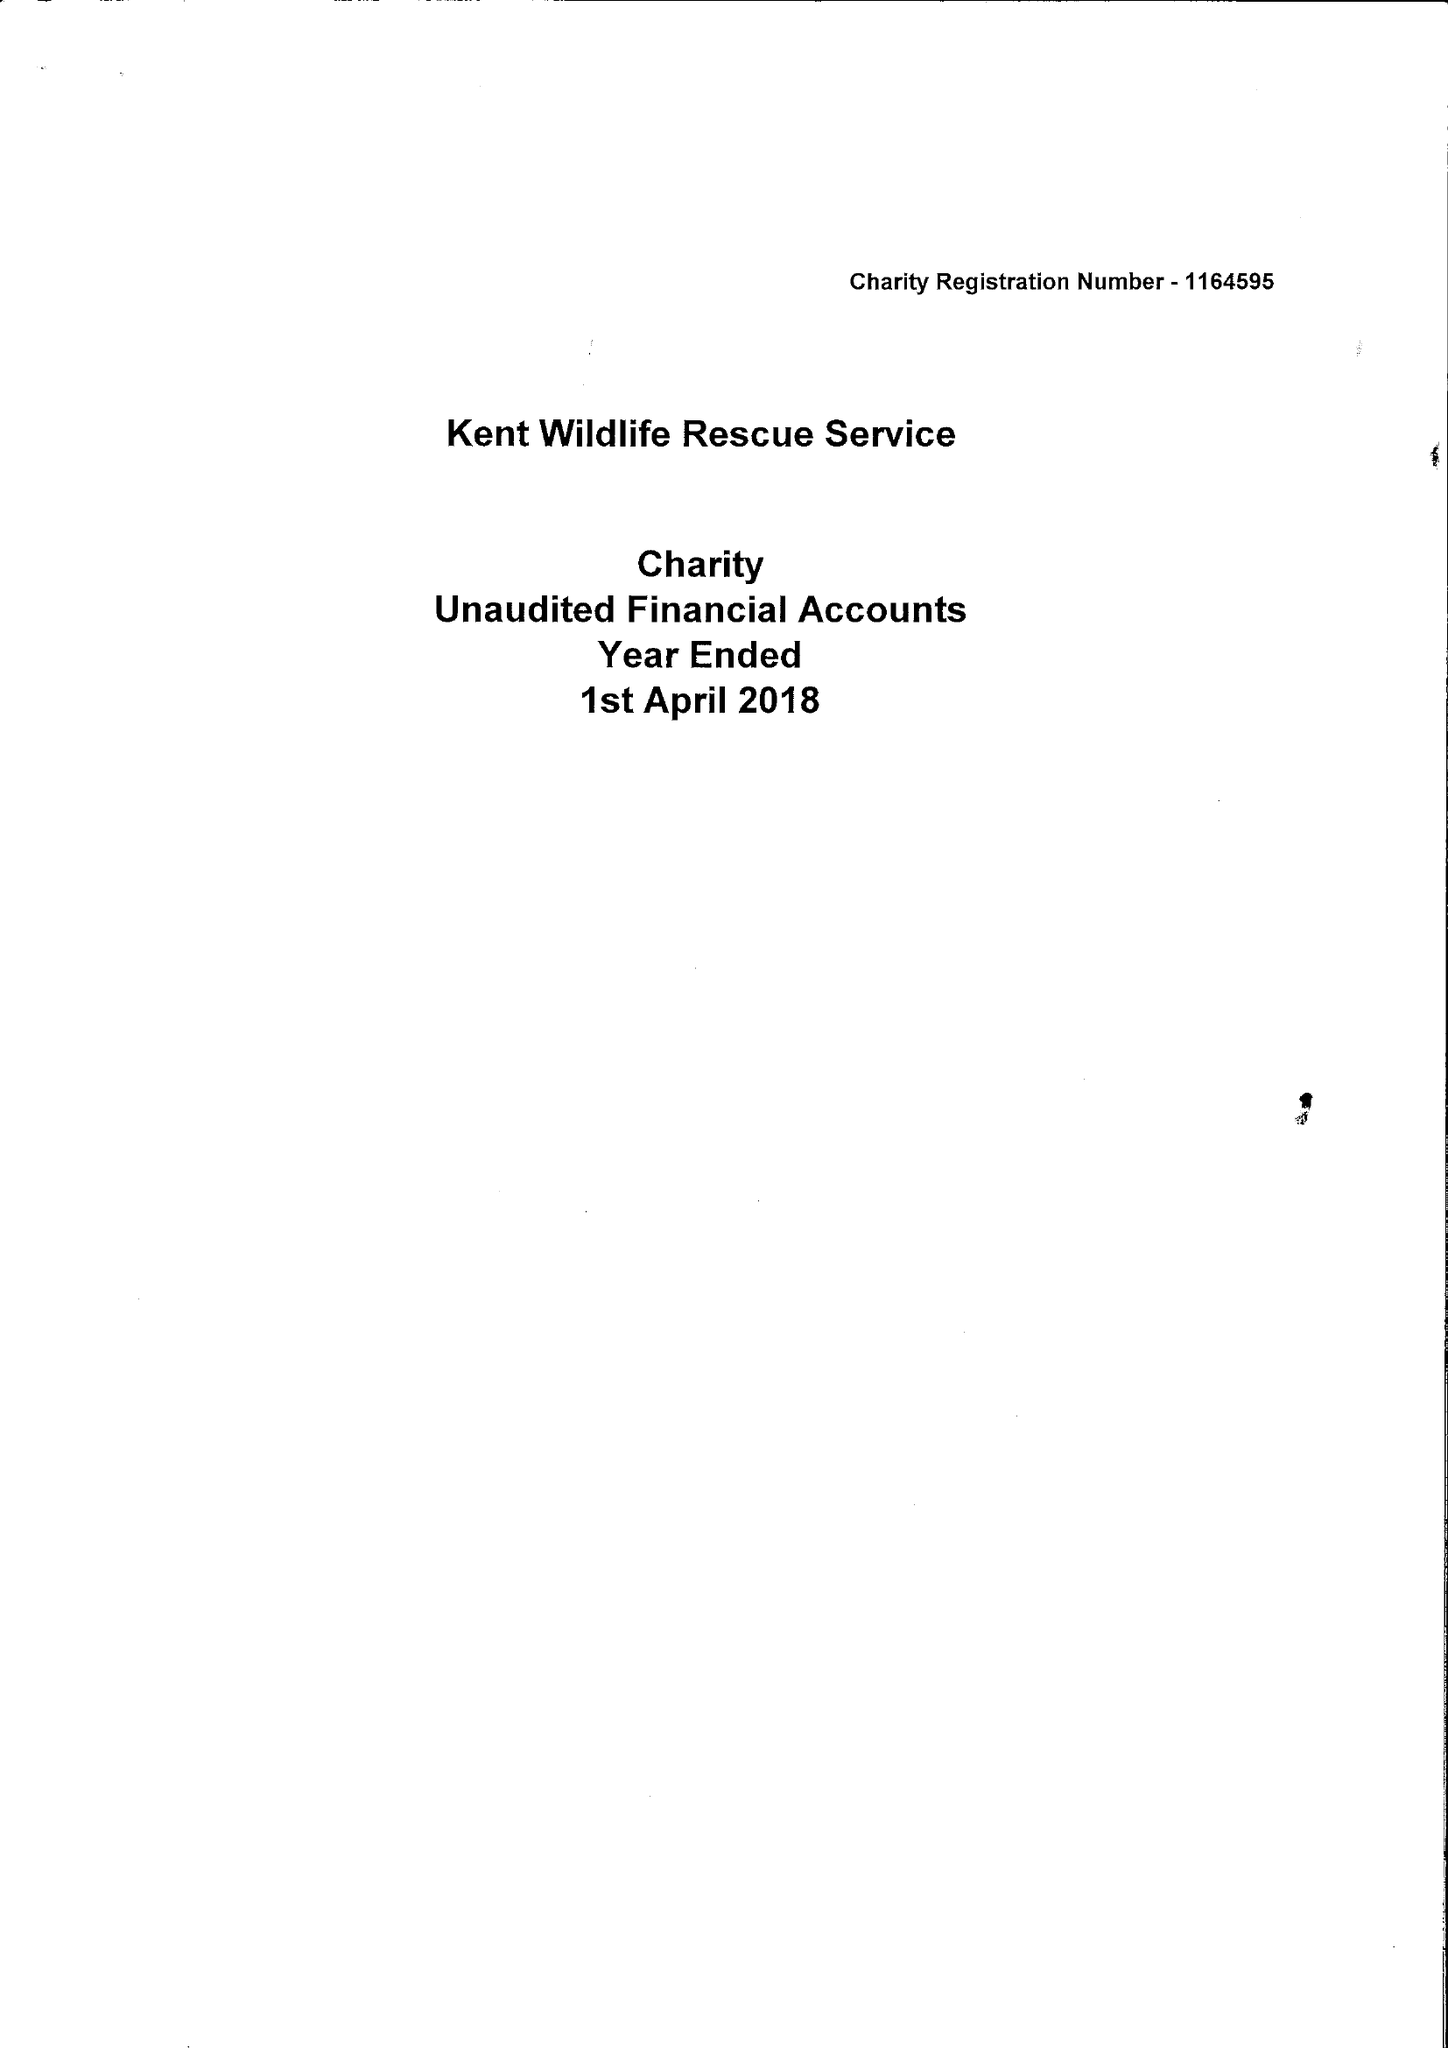What is the value for the address__street_line?
Answer the question using a single word or phrase. 106 VICTORIA STREET 